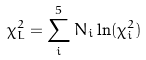Convert formula to latex. <formula><loc_0><loc_0><loc_500><loc_500>\chi _ { L } ^ { 2 } = \sum _ { i } ^ { 5 } N _ { i } \ln ( \chi _ { i } ^ { 2 } )</formula> 